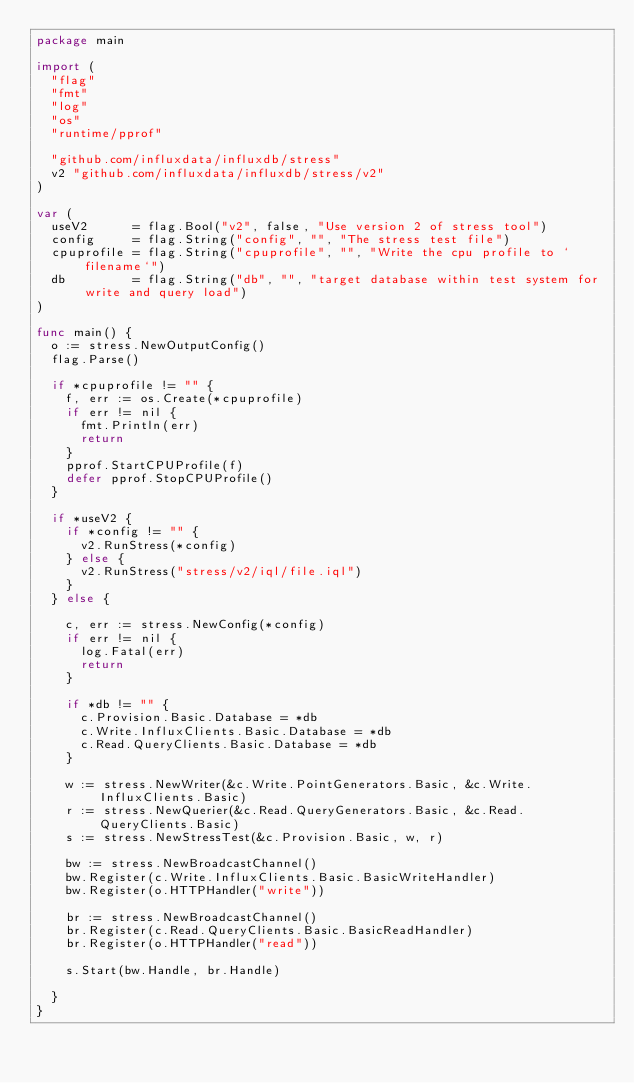Convert code to text. <code><loc_0><loc_0><loc_500><loc_500><_Go_>package main

import (
	"flag"
	"fmt"
	"log"
	"os"
	"runtime/pprof"

	"github.com/influxdata/influxdb/stress"
	v2 "github.com/influxdata/influxdb/stress/v2"
)

var (
	useV2      = flag.Bool("v2", false, "Use version 2 of stress tool")
	config     = flag.String("config", "", "The stress test file")
	cpuprofile = flag.String("cpuprofile", "", "Write the cpu profile to `filename`")
	db         = flag.String("db", "", "target database within test system for write and query load")
)

func main() {
	o := stress.NewOutputConfig()
	flag.Parse()

	if *cpuprofile != "" {
		f, err := os.Create(*cpuprofile)
		if err != nil {
			fmt.Println(err)
			return
		}
		pprof.StartCPUProfile(f)
		defer pprof.StopCPUProfile()
	}

	if *useV2 {
		if *config != "" {
			v2.RunStress(*config)
		} else {
			v2.RunStress("stress/v2/iql/file.iql")
		}
	} else {

		c, err := stress.NewConfig(*config)
		if err != nil {
			log.Fatal(err)
			return
		}

		if *db != "" {
			c.Provision.Basic.Database = *db
			c.Write.InfluxClients.Basic.Database = *db
			c.Read.QueryClients.Basic.Database = *db
		}

		w := stress.NewWriter(&c.Write.PointGenerators.Basic, &c.Write.InfluxClients.Basic)
		r := stress.NewQuerier(&c.Read.QueryGenerators.Basic, &c.Read.QueryClients.Basic)
		s := stress.NewStressTest(&c.Provision.Basic, w, r)

		bw := stress.NewBroadcastChannel()
		bw.Register(c.Write.InfluxClients.Basic.BasicWriteHandler)
		bw.Register(o.HTTPHandler("write"))

		br := stress.NewBroadcastChannel()
		br.Register(c.Read.QueryClients.Basic.BasicReadHandler)
		br.Register(o.HTTPHandler("read"))

		s.Start(bw.Handle, br.Handle)

	}
}
</code> 